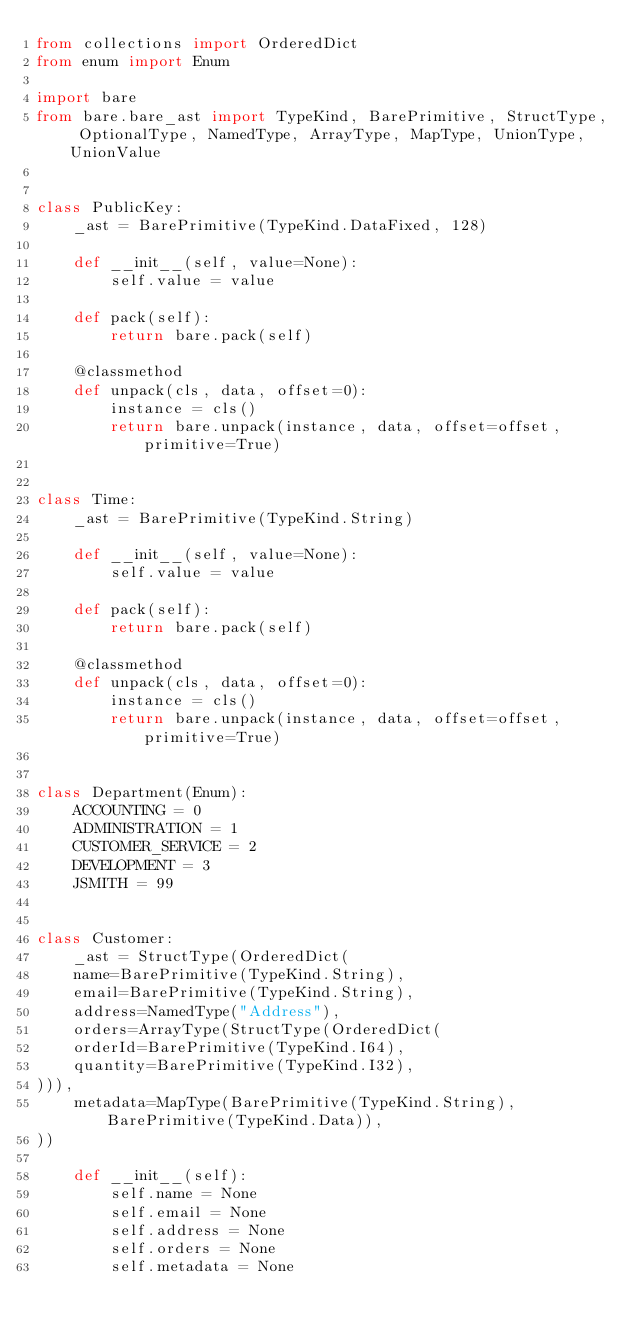Convert code to text. <code><loc_0><loc_0><loc_500><loc_500><_Python_>from collections import OrderedDict
from enum import Enum

import bare
from bare.bare_ast import TypeKind, BarePrimitive, StructType, OptionalType, NamedType, ArrayType, MapType, UnionType, UnionValue


class PublicKey:
	_ast = BarePrimitive(TypeKind.DataFixed, 128)

	def __init__(self, value=None):
		self.value = value

	def pack(self):
		return bare.pack(self)

	@classmethod
	def unpack(cls, data, offset=0):
		instance = cls()
		return bare.unpack(instance, data, offset=offset, primitive=True)


class Time:
	_ast = BarePrimitive(TypeKind.String)

	def __init__(self, value=None):
		self.value = value

	def pack(self):
		return bare.pack(self)

	@classmethod
	def unpack(cls, data, offset=0):
		instance = cls()
		return bare.unpack(instance, data, offset=offset, primitive=True)


class Department(Enum):
	ACCOUNTING = 0
	ADMINISTRATION = 1
	CUSTOMER_SERVICE = 2
	DEVELOPMENT = 3
	JSMITH = 99


class Customer:
	_ast = StructType(OrderedDict(
	name=BarePrimitive(TypeKind.String),
	email=BarePrimitive(TypeKind.String),
	address=NamedType("Address"),
	orders=ArrayType(StructType(OrderedDict(
	orderId=BarePrimitive(TypeKind.I64),
	quantity=BarePrimitive(TypeKind.I32),
))),
	metadata=MapType(BarePrimitive(TypeKind.String), BarePrimitive(TypeKind.Data)),
))

	def __init__(self):
		self.name = None
		self.email = None
		self.address = None
		self.orders = None
		self.metadata = None
</code> 